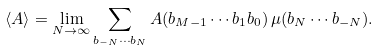<formula> <loc_0><loc_0><loc_500><loc_500>\left \langle A \right \rangle = \lim _ { N \rightarrow \infty } \sum _ { b _ { - N } \cdots b _ { N } } A ( b _ { M - 1 } \cdots b _ { 1 } b _ { 0 } ) \, \mu ( b _ { N } \cdots b _ { - N } ) .</formula> 